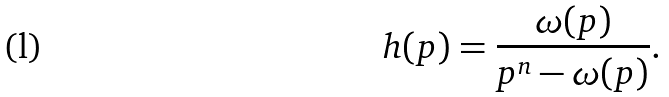<formula> <loc_0><loc_0><loc_500><loc_500>h ( p ) = \frac { \omega ( p ) } { p ^ { n } - \omega ( p ) } .</formula> 